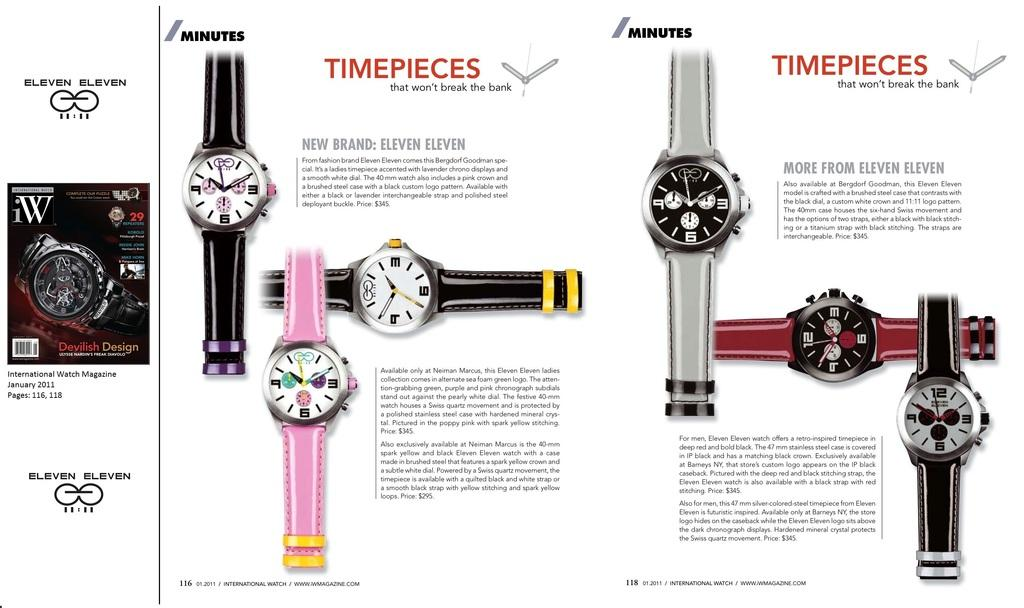Provide a one-sentence caption for the provided image. The watches are made by the brand eleven eleven. 